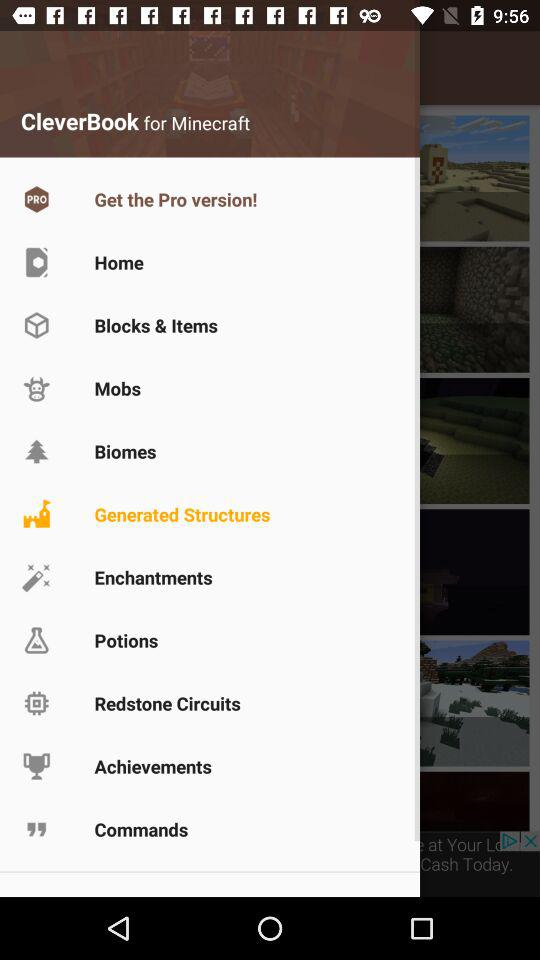What is the application name? The application name is "CleverBook for Minecraft". 